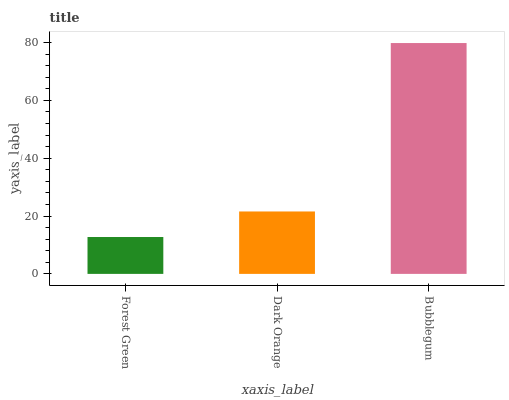Is Forest Green the minimum?
Answer yes or no. Yes. Is Bubblegum the maximum?
Answer yes or no. Yes. Is Dark Orange the minimum?
Answer yes or no. No. Is Dark Orange the maximum?
Answer yes or no. No. Is Dark Orange greater than Forest Green?
Answer yes or no. Yes. Is Forest Green less than Dark Orange?
Answer yes or no. Yes. Is Forest Green greater than Dark Orange?
Answer yes or no. No. Is Dark Orange less than Forest Green?
Answer yes or no. No. Is Dark Orange the high median?
Answer yes or no. Yes. Is Dark Orange the low median?
Answer yes or no. Yes. Is Bubblegum the high median?
Answer yes or no. No. Is Bubblegum the low median?
Answer yes or no. No. 